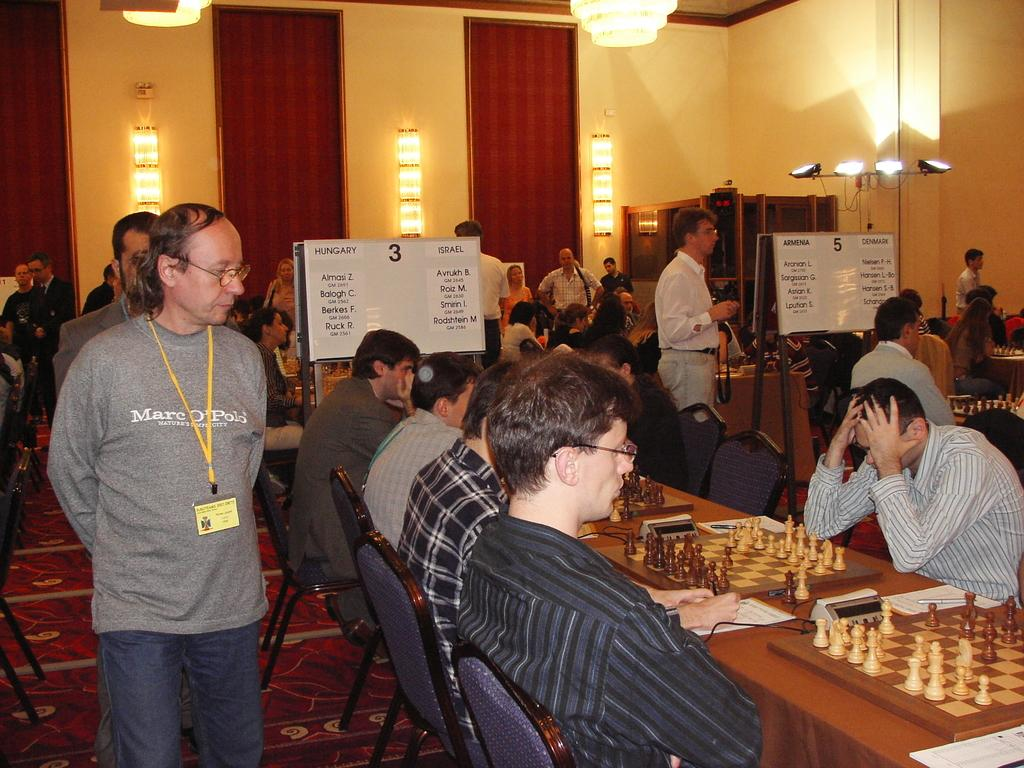What are the people in the image doing? The people are sitting on chairs and playing chess. Can you describe the man walking in the left side of the image? The man is walking in the left side of the image and is wearing an ID card. What is present at the top of the image? There are lights at the top of the image. What type of letters are the people teaching in the image? There is no indication in the image that the people are teaching or that there are any letters present. What kind of oatmeal is being served to the people playing chess? There is no oatmeal present in the image; the people are playing chess with chess pieces and not eating any food. 